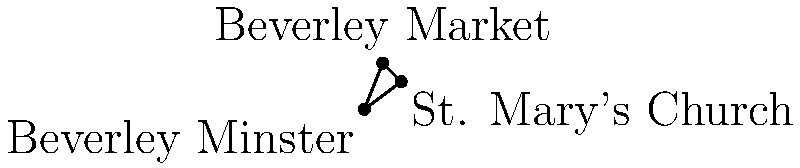On a map of Beverley, three historical landmarks form a triangle: Beverley Minster, St. Mary's Church, and Beverley Market. What is the measure of the angle formed at Beverley Market? To find the angle at Beverley Market, we can use the law of cosines:

1) Let's assign sides:
   a = distance between Beverley Minster and St. Mary's Church
   b = distance between Beverley Minster and Beverley Market
   c = distance between St. Mary's Church and Beverley Market

2) The law of cosines states:
   $$c^2 = a^2 + b^2 - 2ab \cos(C)$$
   where C is the angle we're looking for at Beverley Market.

3) From the coordinates:
   Beverley Minster: (0,0)
   St. Mary's Church: (4,3)
   Beverley Market: (2,5)

4) Calculate the distances:
   $$a = \sqrt{4^2 + 3^2} = 5$$
   $$b = \sqrt{2^2 + 5^2} = \sqrt{29}$$
   $$c = \sqrt{2^2 + 2^2} = 2\sqrt{2}$$

5) Plug into the law of cosines:
   $$(2\sqrt{2})^2 = 5^2 + (\sqrt{29})^2 - 2(5)(\sqrt{29}) \cos(C)$$

6) Simplify:
   $$8 = 25 + 29 - 10\sqrt{29} \cos(C)$$
   $$10\sqrt{29} \cos(C) = 46$$
   $$\cos(C) = \frac{46}{10\sqrt{29}}$$

7) Take the inverse cosine (arccos) of both sides:
   $$C = \arccos(\frac{46}{10\sqrt{29}}) \approx 53.13°$$
Answer: $53.13°$ 